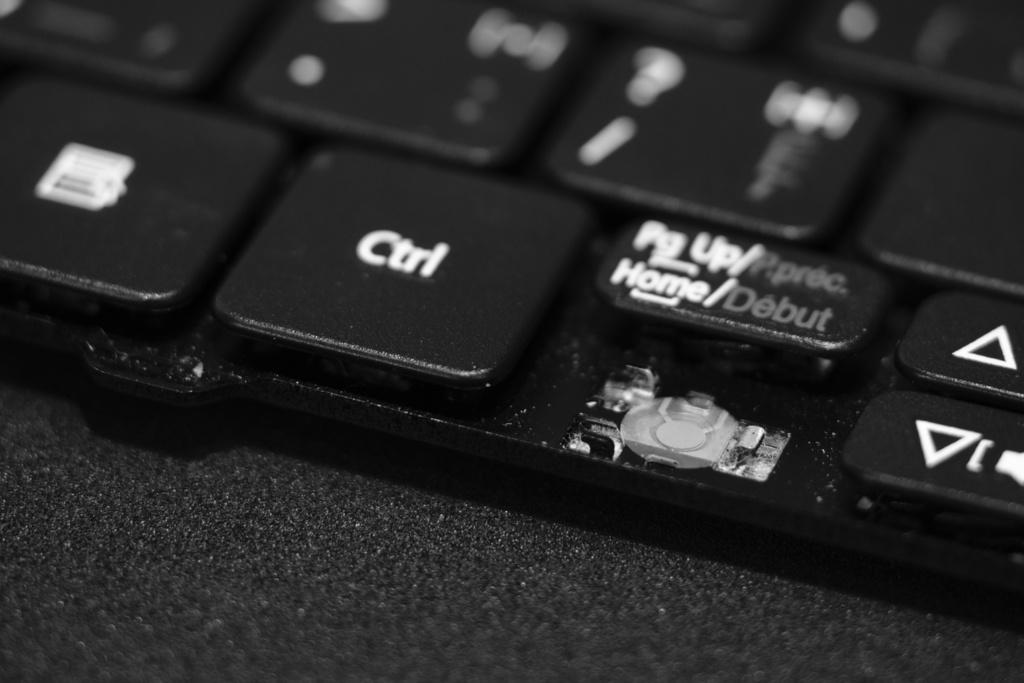Provide a one-sentence caption for the provided image. One of the button to go left is missing on the keyboard. 